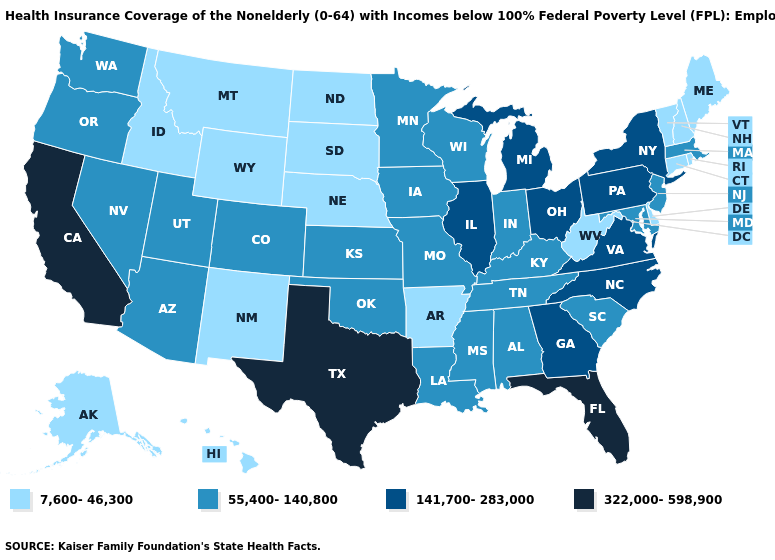Among the states that border Connecticut , does New York have the highest value?
Short answer required. Yes. Is the legend a continuous bar?
Short answer required. No. What is the value of Montana?
Write a very short answer. 7,600-46,300. Does Arizona have the lowest value in the West?
Concise answer only. No. What is the lowest value in states that border North Carolina?
Answer briefly. 55,400-140,800. What is the value of Arizona?
Short answer required. 55,400-140,800. What is the value of Nebraska?
Keep it brief. 7,600-46,300. Does the first symbol in the legend represent the smallest category?
Quick response, please. Yes. Name the states that have a value in the range 141,700-283,000?
Be succinct. Georgia, Illinois, Michigan, New York, North Carolina, Ohio, Pennsylvania, Virginia. Name the states that have a value in the range 55,400-140,800?
Write a very short answer. Alabama, Arizona, Colorado, Indiana, Iowa, Kansas, Kentucky, Louisiana, Maryland, Massachusetts, Minnesota, Mississippi, Missouri, Nevada, New Jersey, Oklahoma, Oregon, South Carolina, Tennessee, Utah, Washington, Wisconsin. What is the highest value in the USA?
Answer briefly. 322,000-598,900. Which states hav the highest value in the South?
Answer briefly. Florida, Texas. What is the value of Hawaii?
Answer briefly. 7,600-46,300. What is the value of Michigan?
Keep it brief. 141,700-283,000. Does California have the highest value in the USA?
Be succinct. Yes. 